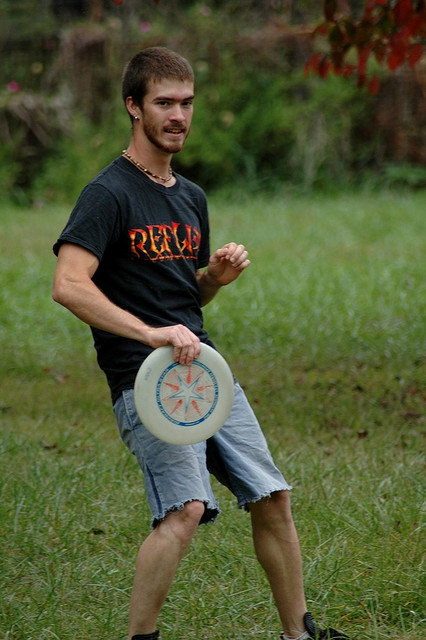Describe the objects in this image and their specific colors. I can see people in darkgreen, black, olive, and gray tones and frisbee in darkgreen, darkgray, and gray tones in this image. 